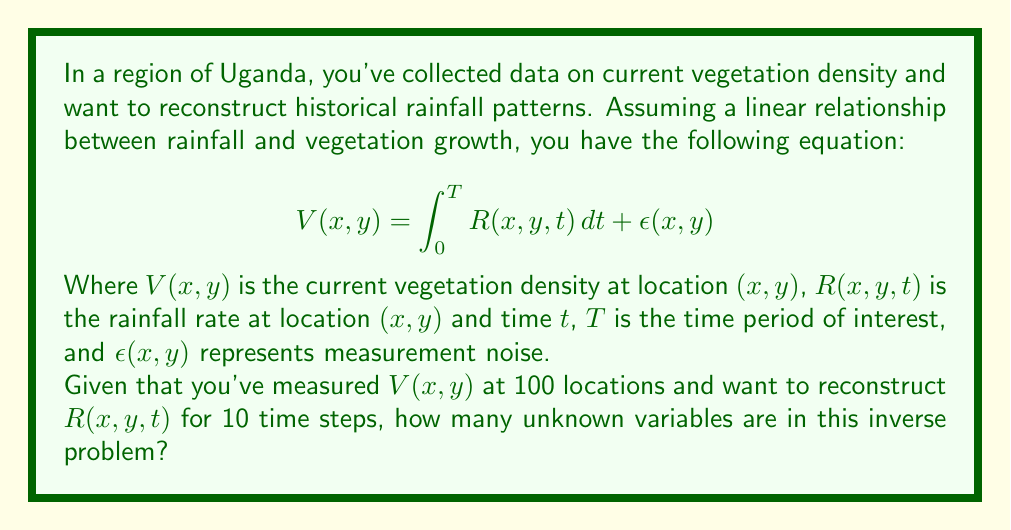Can you answer this question? To solve this inverse problem, we need to determine the number of unknown variables. Let's break it down step-by-step:

1. We are trying to reconstruct $R(x, y, t)$, which is a function of three variables: x, y, and t.

2. We have measurements at 100 locations, which means we have 100 different (x, y) pairs.

3. We want to reconstruct the rainfall for 10 time steps.

4. For each location and time step, we need to determine a single value of $R(x, y, t)$.

5. Therefore, the total number of unknown variables is:
   Number of locations × Number of time steps
   = 100 × 10 = 1000

This means we need to determine 1000 individual values of $R(x, y, t)$ to fully reconstruct the historical rainfall patterns from the given vegetation distribution data.

Note that this is a simplified model, and in reality, the relationship between rainfall and vegetation growth may be more complex, potentially requiring more sophisticated inverse problem techniques.
Answer: 1000 unknown variables 